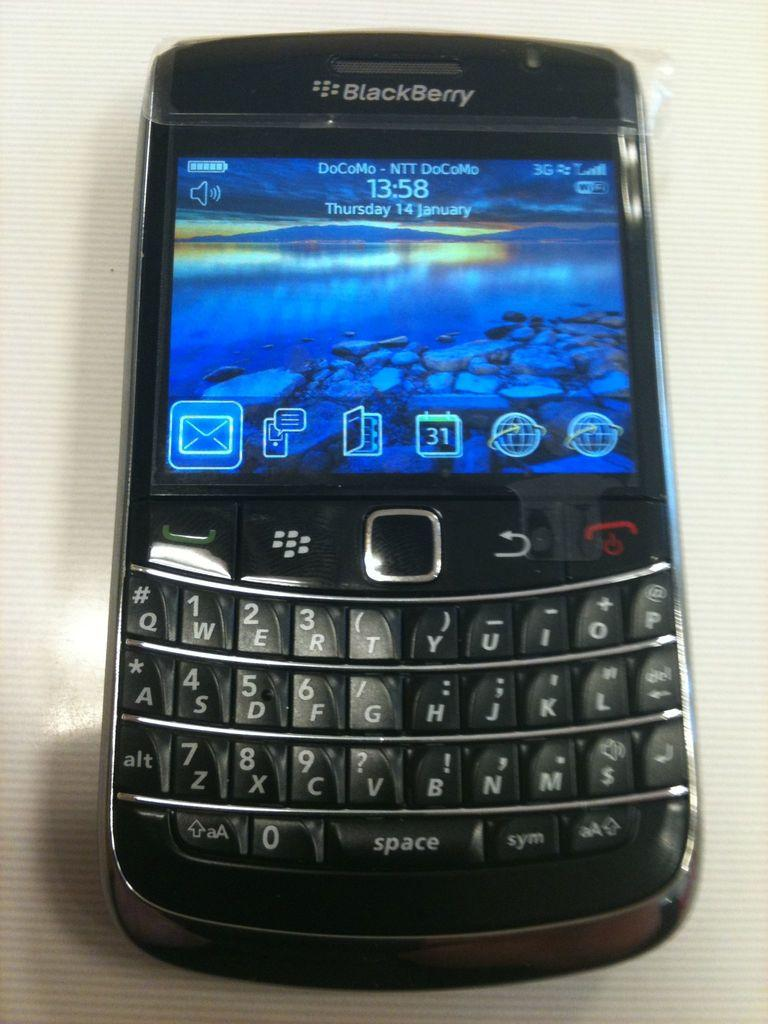Provide a one-sentence caption for the provided image. A DoCoMo BlackBerry displays a rocky river bank at dusk. 